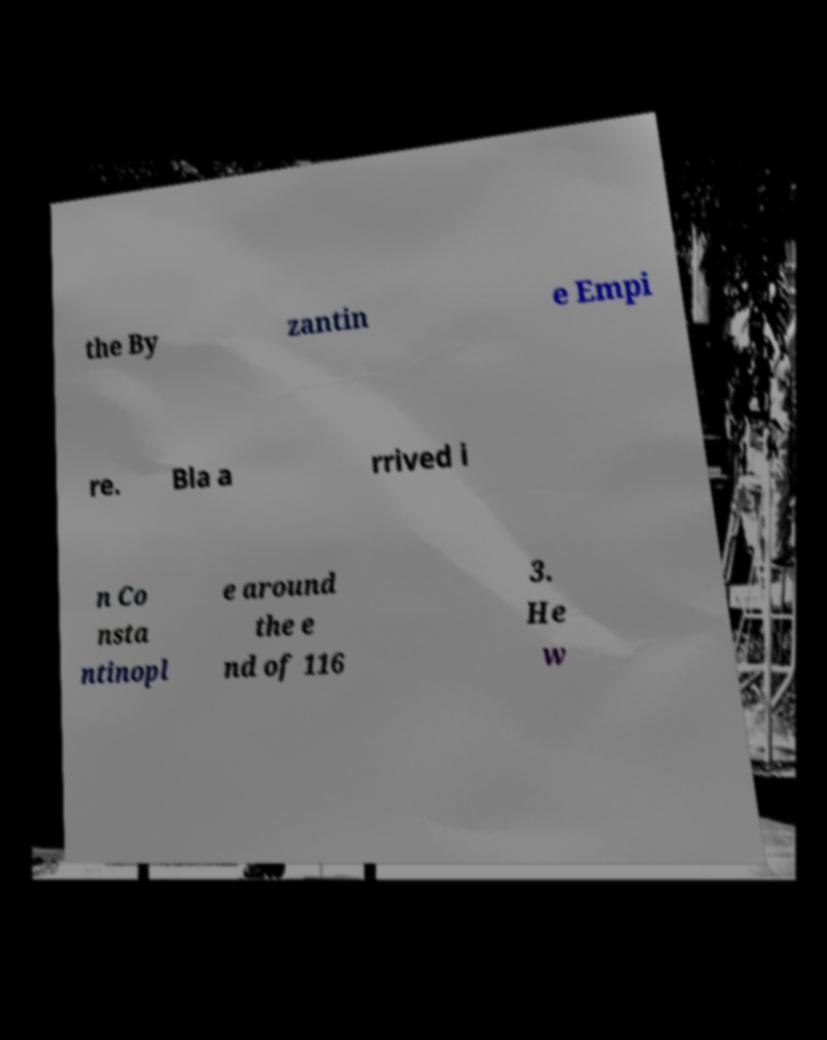Can you accurately transcribe the text from the provided image for me? the By zantin e Empi re. Bla a rrived i n Co nsta ntinopl e around the e nd of 116 3. He w 